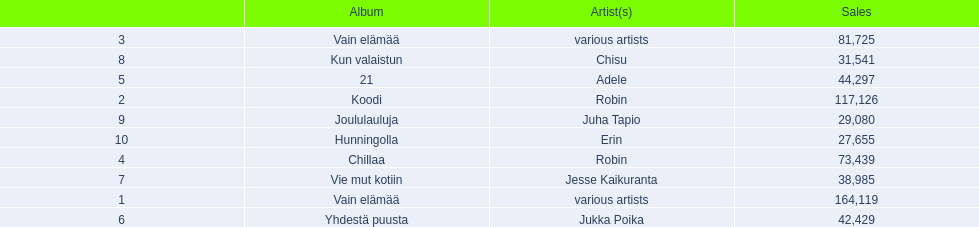What are all the album titles? Vain elämää, Koodi, Vain elämää, Chillaa, 21, Yhdestä puusta, Vie mut kotiin, Kun valaistun, Joululauluja, Hunningolla. Which artists were on the albums? Various artists, robin, various artists, robin, adele, jukka poika, jesse kaikuranta, chisu, juha tapio, erin. Along with chillaa, which other album featured robin? Koodi. 